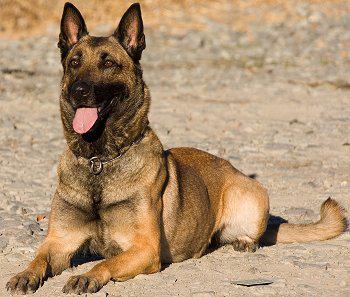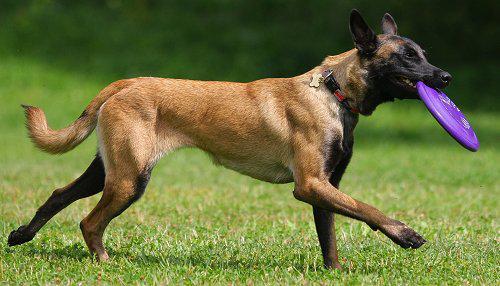The first image is the image on the left, the second image is the image on the right. Examine the images to the left and right. Is the description "In one of the images, a dog can be seen running in a green grassy area facing rightward." accurate? Answer yes or no. Yes. The first image is the image on the left, the second image is the image on the right. For the images shown, is this caption "A dog is moving rightward across the grass, with at least two paws off the ground." true? Answer yes or no. Yes. 